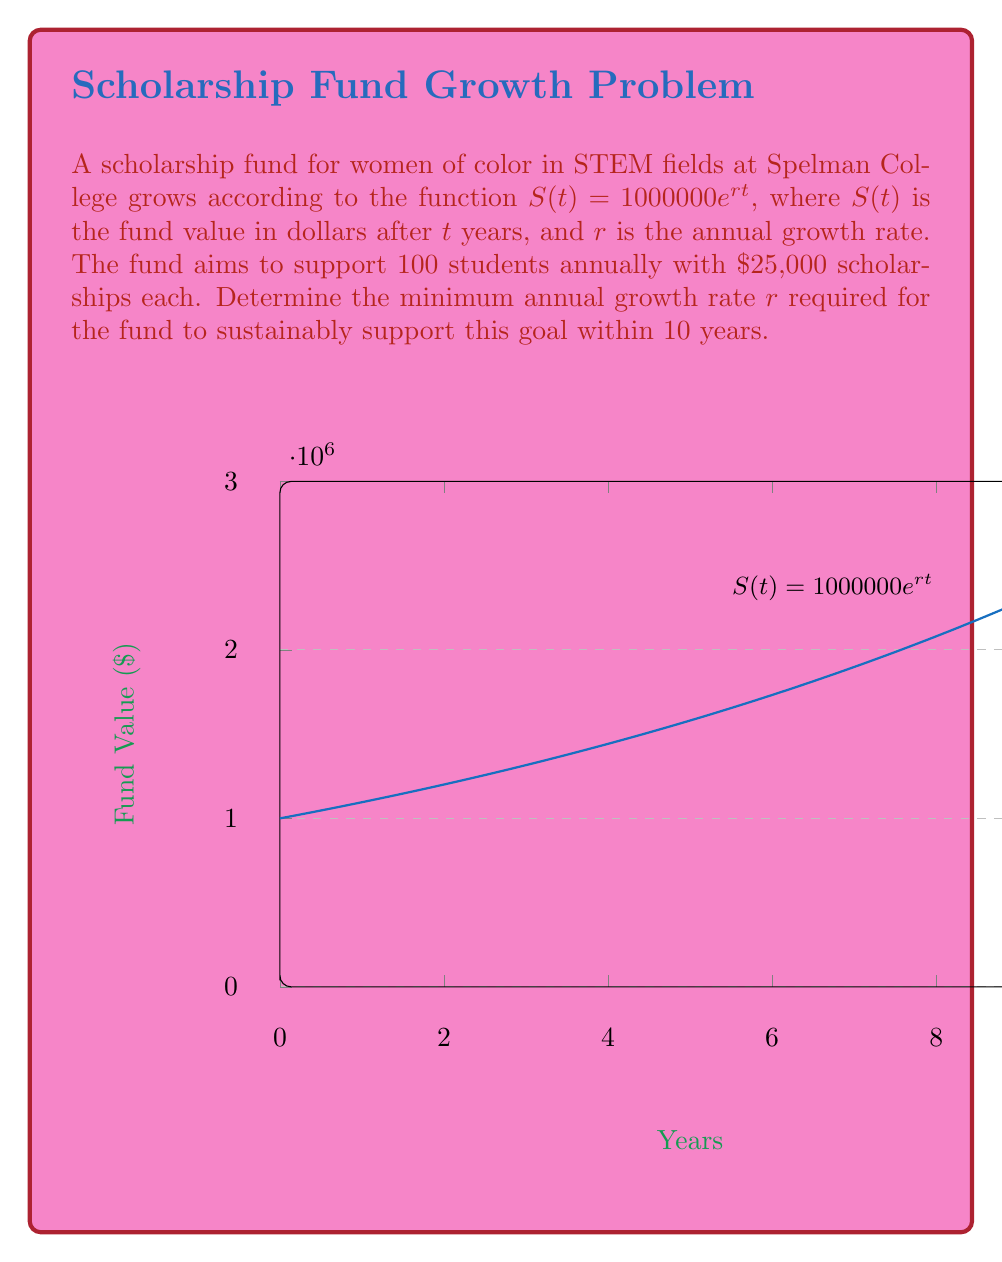Teach me how to tackle this problem. Let's approach this step-by-step:

1) The goal is to support 100 students with $25,000 each annually. So the total needed per year is:
   $$100 \times 25000 = 2500000$$

2) We need to find $r$ such that after 10 years, the fund value is at least $2,500,000:
   $$S(10) = 1000000e^{10r} \geq 2500000$$

3) Let's solve this inequality:
   $$1000000e^{10r} \geq 2500000$$
   $$e^{10r} \geq 2.5$$

4) Taking the natural log of both sides:
   $$10r \geq \ln(2.5)$$

5) Solving for $r$:
   $$r \geq \frac{\ln(2.5)}{10}$$

6) Calculate this value:
   $$r \geq \frac{\ln(2.5)}{10} \approx 0.0916$$

7) Therefore, the minimum annual growth rate needed is approximately 9.16%.
Answer: $r \approx 0.0916$ or $9.16\%$ 